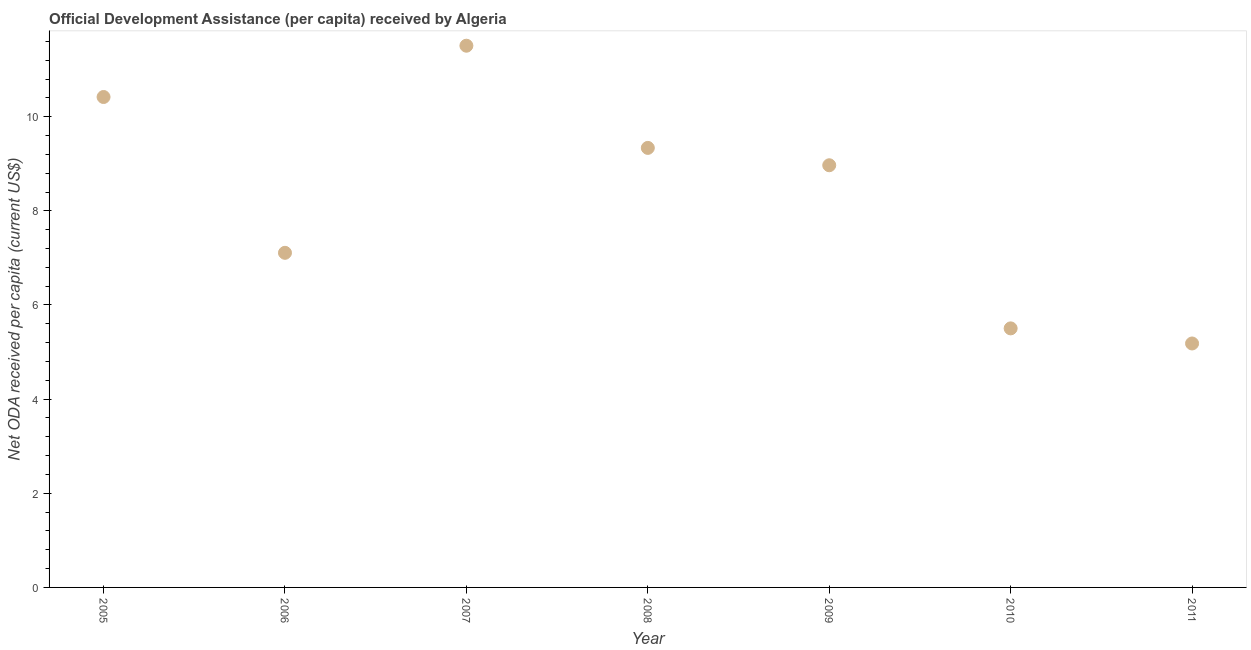What is the net oda received per capita in 2011?
Offer a very short reply. 5.18. Across all years, what is the maximum net oda received per capita?
Provide a succinct answer. 11.51. Across all years, what is the minimum net oda received per capita?
Ensure brevity in your answer.  5.18. In which year was the net oda received per capita maximum?
Ensure brevity in your answer.  2007. What is the sum of the net oda received per capita?
Your answer should be very brief. 58.03. What is the difference between the net oda received per capita in 2007 and 2011?
Keep it short and to the point. 6.33. What is the average net oda received per capita per year?
Offer a terse response. 8.29. What is the median net oda received per capita?
Offer a very short reply. 8.97. Do a majority of the years between 2005 and 2011 (inclusive) have net oda received per capita greater than 10 US$?
Ensure brevity in your answer.  No. What is the ratio of the net oda received per capita in 2007 to that in 2009?
Make the answer very short. 1.28. What is the difference between the highest and the second highest net oda received per capita?
Give a very brief answer. 1.09. Is the sum of the net oda received per capita in 2009 and 2010 greater than the maximum net oda received per capita across all years?
Offer a very short reply. Yes. What is the difference between the highest and the lowest net oda received per capita?
Ensure brevity in your answer.  6.33. How many years are there in the graph?
Keep it short and to the point. 7. What is the difference between two consecutive major ticks on the Y-axis?
Provide a short and direct response. 2. Does the graph contain grids?
Your response must be concise. No. What is the title of the graph?
Provide a short and direct response. Official Development Assistance (per capita) received by Algeria. What is the label or title of the Y-axis?
Provide a succinct answer. Net ODA received per capita (current US$). What is the Net ODA received per capita (current US$) in 2005?
Ensure brevity in your answer.  10.42. What is the Net ODA received per capita (current US$) in 2006?
Provide a succinct answer. 7.11. What is the Net ODA received per capita (current US$) in 2007?
Your answer should be very brief. 11.51. What is the Net ODA received per capita (current US$) in 2008?
Provide a short and direct response. 9.34. What is the Net ODA received per capita (current US$) in 2009?
Your response must be concise. 8.97. What is the Net ODA received per capita (current US$) in 2010?
Ensure brevity in your answer.  5.5. What is the Net ODA received per capita (current US$) in 2011?
Provide a succinct answer. 5.18. What is the difference between the Net ODA received per capita (current US$) in 2005 and 2006?
Provide a succinct answer. 3.31. What is the difference between the Net ODA received per capita (current US$) in 2005 and 2007?
Give a very brief answer. -1.09. What is the difference between the Net ODA received per capita (current US$) in 2005 and 2008?
Provide a short and direct response. 1.08. What is the difference between the Net ODA received per capita (current US$) in 2005 and 2009?
Provide a short and direct response. 1.45. What is the difference between the Net ODA received per capita (current US$) in 2005 and 2010?
Offer a terse response. 4.92. What is the difference between the Net ODA received per capita (current US$) in 2005 and 2011?
Provide a short and direct response. 5.24. What is the difference between the Net ODA received per capita (current US$) in 2006 and 2007?
Your answer should be very brief. -4.4. What is the difference between the Net ODA received per capita (current US$) in 2006 and 2008?
Your response must be concise. -2.23. What is the difference between the Net ODA received per capita (current US$) in 2006 and 2009?
Ensure brevity in your answer.  -1.86. What is the difference between the Net ODA received per capita (current US$) in 2006 and 2010?
Your response must be concise. 1.61. What is the difference between the Net ODA received per capita (current US$) in 2006 and 2011?
Offer a very short reply. 1.93. What is the difference between the Net ODA received per capita (current US$) in 2007 and 2008?
Ensure brevity in your answer.  2.17. What is the difference between the Net ODA received per capita (current US$) in 2007 and 2009?
Your answer should be very brief. 2.54. What is the difference between the Net ODA received per capita (current US$) in 2007 and 2010?
Make the answer very short. 6.01. What is the difference between the Net ODA received per capita (current US$) in 2007 and 2011?
Offer a terse response. 6.33. What is the difference between the Net ODA received per capita (current US$) in 2008 and 2009?
Your answer should be compact. 0.37. What is the difference between the Net ODA received per capita (current US$) in 2008 and 2010?
Offer a terse response. 3.83. What is the difference between the Net ODA received per capita (current US$) in 2008 and 2011?
Offer a terse response. 4.15. What is the difference between the Net ODA received per capita (current US$) in 2009 and 2010?
Give a very brief answer. 3.47. What is the difference between the Net ODA received per capita (current US$) in 2009 and 2011?
Provide a short and direct response. 3.79. What is the difference between the Net ODA received per capita (current US$) in 2010 and 2011?
Give a very brief answer. 0.32. What is the ratio of the Net ODA received per capita (current US$) in 2005 to that in 2006?
Make the answer very short. 1.47. What is the ratio of the Net ODA received per capita (current US$) in 2005 to that in 2007?
Give a very brief answer. 0.91. What is the ratio of the Net ODA received per capita (current US$) in 2005 to that in 2008?
Your answer should be compact. 1.12. What is the ratio of the Net ODA received per capita (current US$) in 2005 to that in 2009?
Offer a very short reply. 1.16. What is the ratio of the Net ODA received per capita (current US$) in 2005 to that in 2010?
Your answer should be compact. 1.89. What is the ratio of the Net ODA received per capita (current US$) in 2005 to that in 2011?
Your response must be concise. 2.01. What is the ratio of the Net ODA received per capita (current US$) in 2006 to that in 2007?
Provide a short and direct response. 0.62. What is the ratio of the Net ODA received per capita (current US$) in 2006 to that in 2008?
Your answer should be compact. 0.76. What is the ratio of the Net ODA received per capita (current US$) in 2006 to that in 2009?
Your response must be concise. 0.79. What is the ratio of the Net ODA received per capita (current US$) in 2006 to that in 2010?
Provide a succinct answer. 1.29. What is the ratio of the Net ODA received per capita (current US$) in 2006 to that in 2011?
Your answer should be very brief. 1.37. What is the ratio of the Net ODA received per capita (current US$) in 2007 to that in 2008?
Provide a succinct answer. 1.23. What is the ratio of the Net ODA received per capita (current US$) in 2007 to that in 2009?
Ensure brevity in your answer.  1.28. What is the ratio of the Net ODA received per capita (current US$) in 2007 to that in 2010?
Offer a terse response. 2.09. What is the ratio of the Net ODA received per capita (current US$) in 2007 to that in 2011?
Your answer should be compact. 2.22. What is the ratio of the Net ODA received per capita (current US$) in 2008 to that in 2009?
Your answer should be compact. 1.04. What is the ratio of the Net ODA received per capita (current US$) in 2008 to that in 2010?
Keep it short and to the point. 1.7. What is the ratio of the Net ODA received per capita (current US$) in 2008 to that in 2011?
Your answer should be very brief. 1.8. What is the ratio of the Net ODA received per capita (current US$) in 2009 to that in 2010?
Your answer should be compact. 1.63. What is the ratio of the Net ODA received per capita (current US$) in 2009 to that in 2011?
Make the answer very short. 1.73. What is the ratio of the Net ODA received per capita (current US$) in 2010 to that in 2011?
Ensure brevity in your answer.  1.06. 